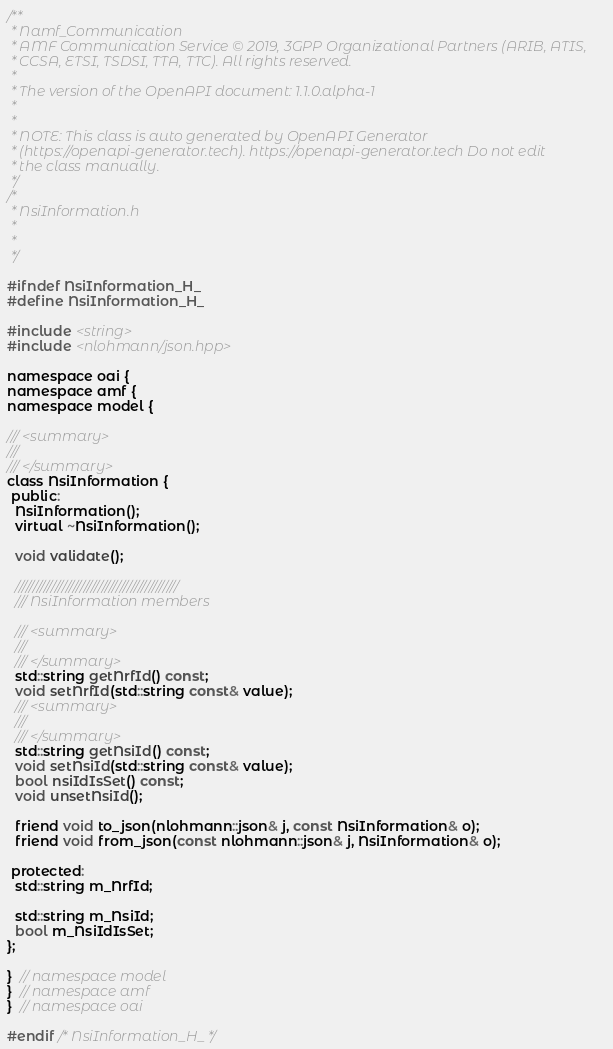Convert code to text. <code><loc_0><loc_0><loc_500><loc_500><_C_>/**
 * Namf_Communication
 * AMF Communication Service © 2019, 3GPP Organizational Partners (ARIB, ATIS,
 * CCSA, ETSI, TSDSI, TTA, TTC). All rights reserved.
 *
 * The version of the OpenAPI document: 1.1.0.alpha-1
 *
 *
 * NOTE: This class is auto generated by OpenAPI Generator
 * (https://openapi-generator.tech). https://openapi-generator.tech Do not edit
 * the class manually.
 */
/*
 * NsiInformation.h
 *
 *
 */

#ifndef NsiInformation_H_
#define NsiInformation_H_

#include <string>
#include <nlohmann/json.hpp>

namespace oai {
namespace amf {
namespace model {

/// <summary>
///
/// </summary>
class NsiInformation {
 public:
  NsiInformation();
  virtual ~NsiInformation();

  void validate();

  /////////////////////////////////////////////
  /// NsiInformation members

  /// <summary>
  ///
  /// </summary>
  std::string getNrfId() const;
  void setNrfId(std::string const& value);
  /// <summary>
  ///
  /// </summary>
  std::string getNsiId() const;
  void setNsiId(std::string const& value);
  bool nsiIdIsSet() const;
  void unsetNsiId();

  friend void to_json(nlohmann::json& j, const NsiInformation& o);
  friend void from_json(const nlohmann::json& j, NsiInformation& o);

 protected:
  std::string m_NrfId;

  std::string m_NsiId;
  bool m_NsiIdIsSet;
};

}  // namespace model
}  // namespace amf
}  // namespace oai

#endif /* NsiInformation_H_ */
</code> 